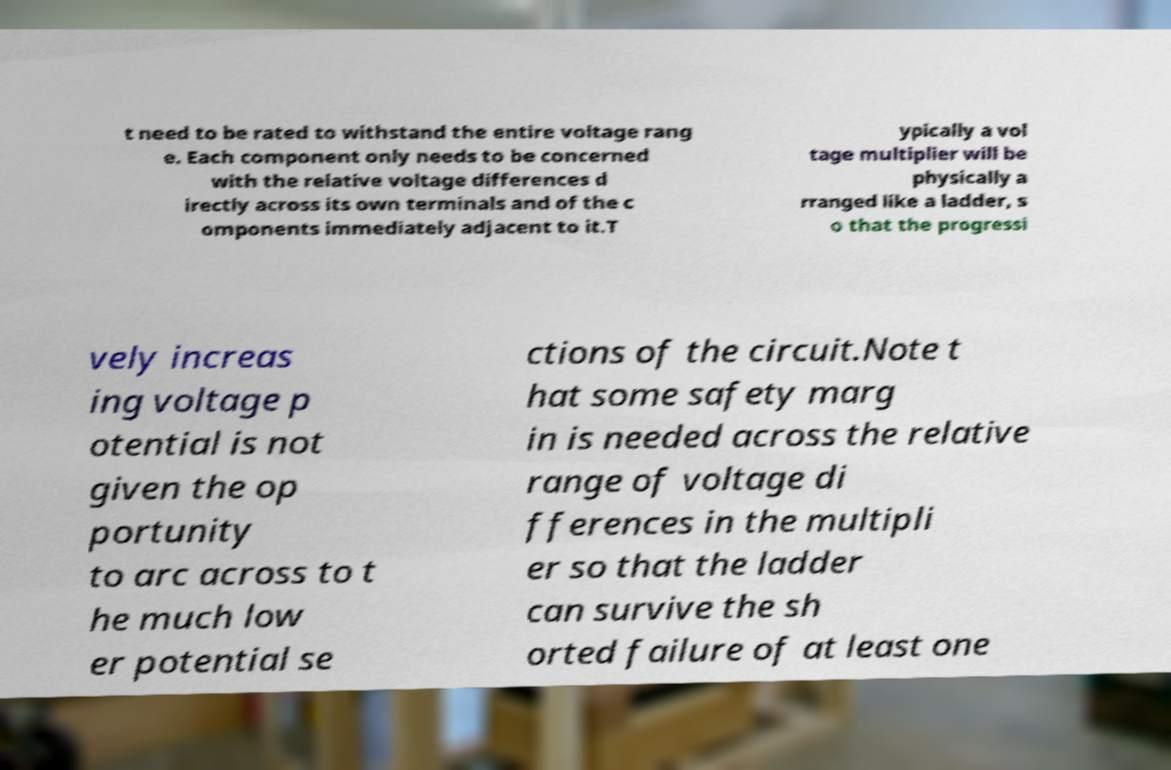Please identify and transcribe the text found in this image. t need to be rated to withstand the entire voltage rang e. Each component only needs to be concerned with the relative voltage differences d irectly across its own terminals and of the c omponents immediately adjacent to it.T ypically a vol tage multiplier will be physically a rranged like a ladder, s o that the progressi vely increas ing voltage p otential is not given the op portunity to arc across to t he much low er potential se ctions of the circuit.Note t hat some safety marg in is needed across the relative range of voltage di fferences in the multipli er so that the ladder can survive the sh orted failure of at least one 